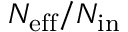<formula> <loc_0><loc_0><loc_500><loc_500>{ N _ { e f f } } / { N _ { i n } }</formula> 